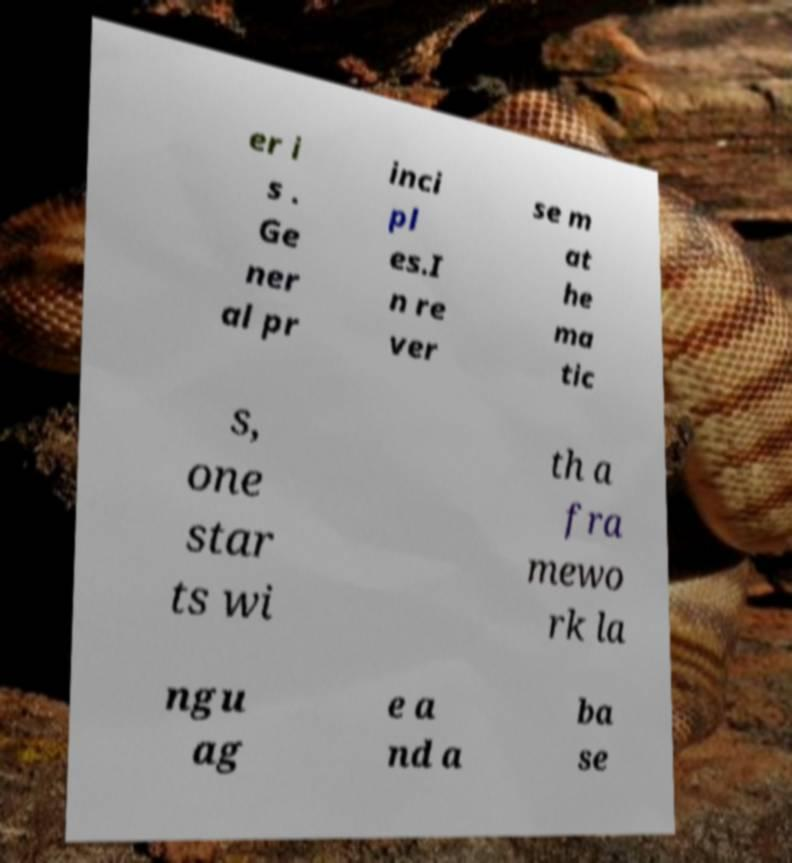I need the written content from this picture converted into text. Can you do that? er i s . Ge ner al pr inci pl es.I n re ver se m at he ma tic s, one star ts wi th a fra mewo rk la ngu ag e a nd a ba se 